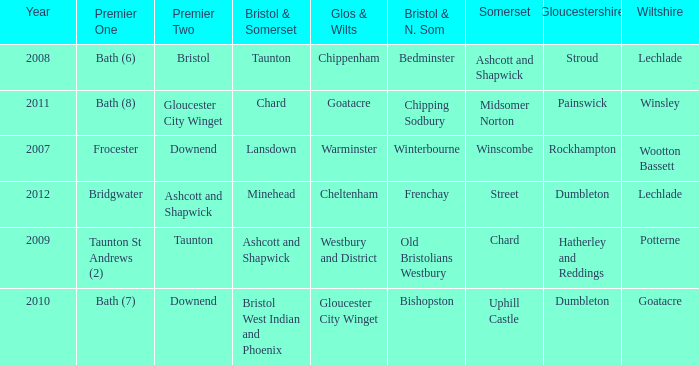What is the bristol & n. som where the somerset is ashcott and shapwick? Bedminster. 